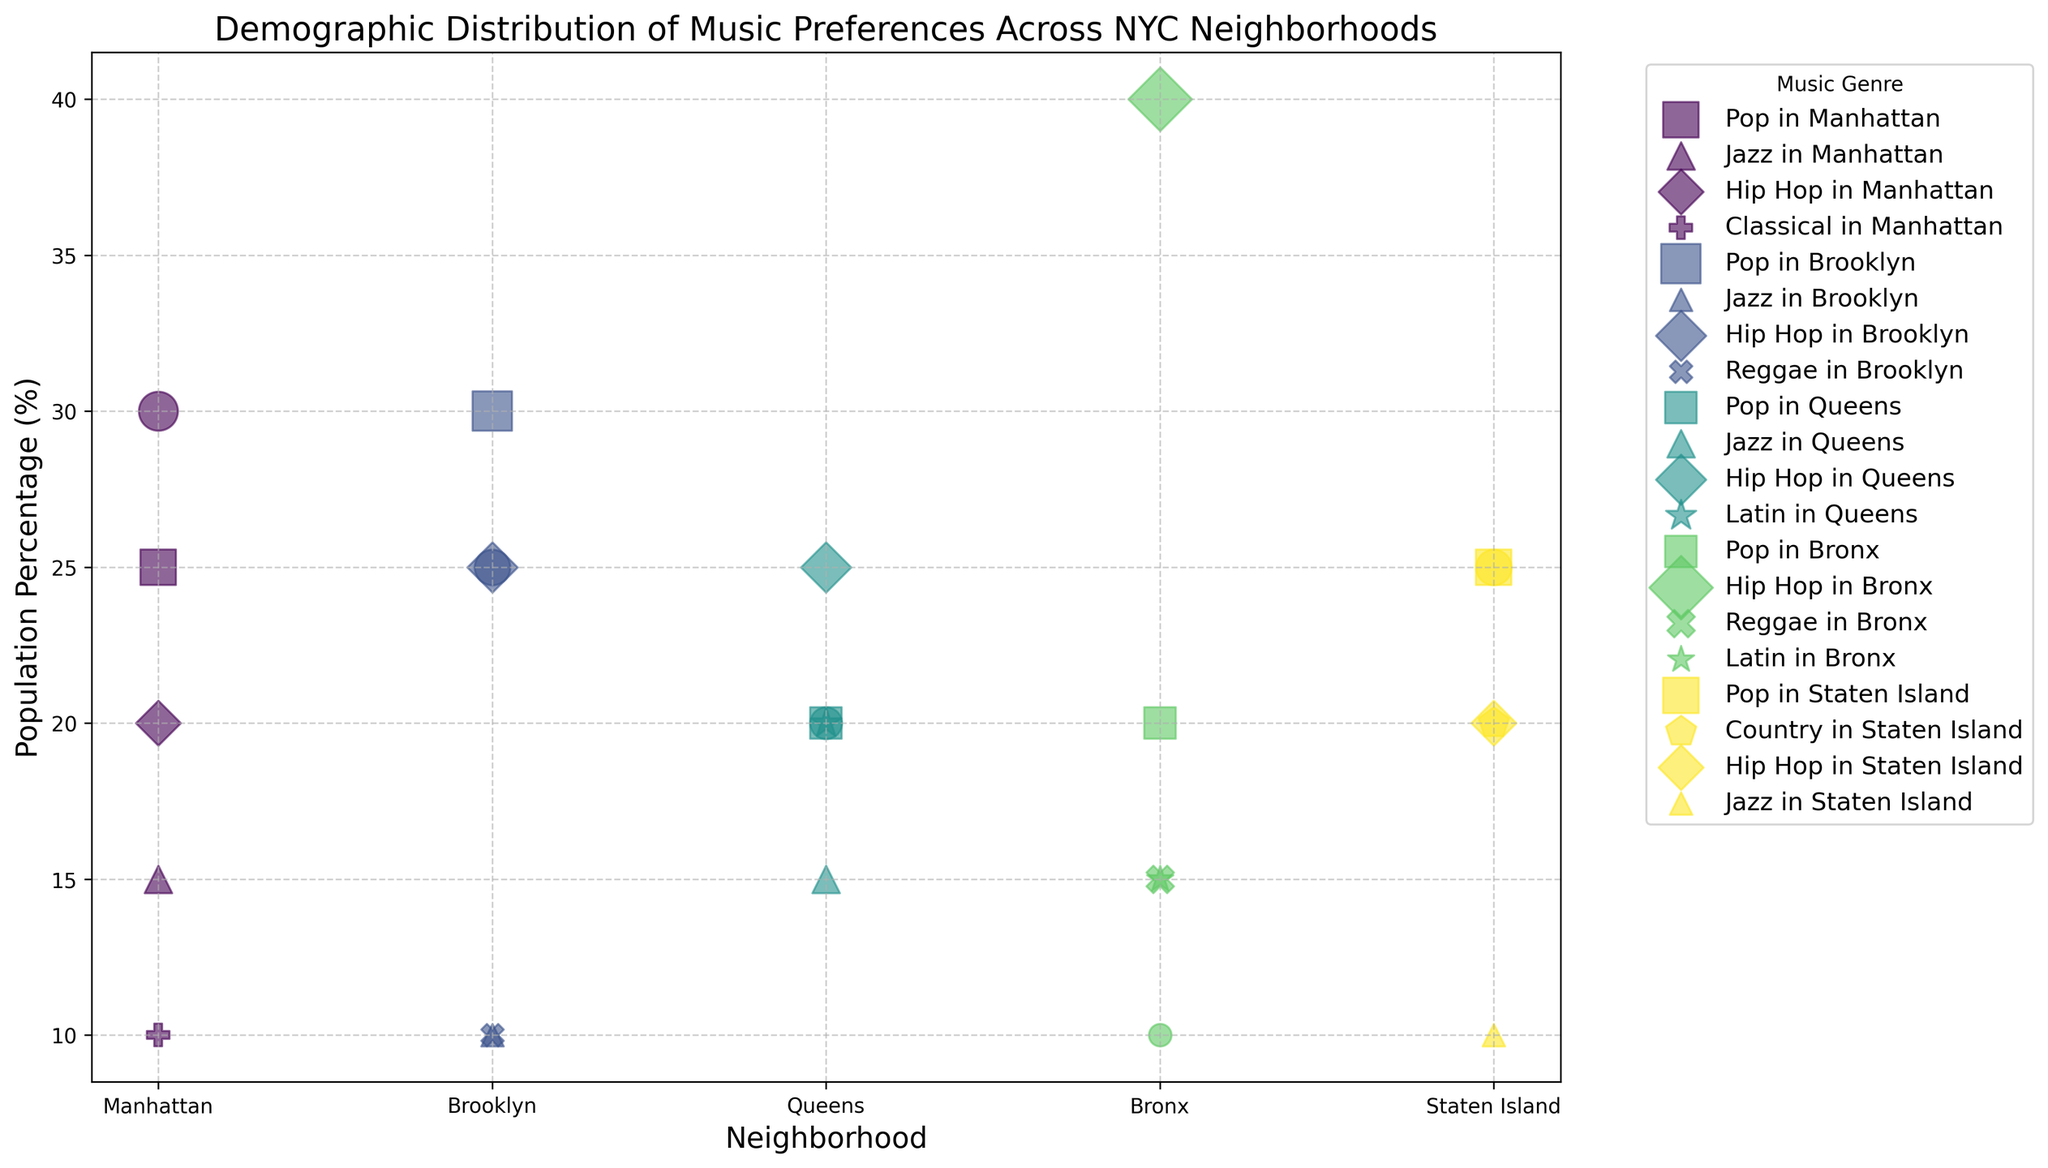What's the musical genre with the highest popularity in the Bronx? Look at which bubble has the largest y-value (population percentage) in the Bronx. The bubble representing Hip Hop has the highest percentage at 40%.
Answer: Hip Hop Which neighborhood has the highest population percentage for Jazz? Compare the y-values (population percentages) of Jazz across all neighborhoods. The highest y-value for Jazz is in Manhattan at 15%.
Answer: Manhattan Between Brooklyn and Staten Island, which neighborhood has a greater percentage of Pop listeners? Compare the Pop bubbles in Brooklyn and Staten Island. Both have y-values of 25% for Pop listeners.
Answer: Equal What's the average population percentage of Rock listeners in NYC? Sum the Rock population percentages across all neighborhoods (30 + 25 + 20 + 10 + 25 = 110) and divide by the number of neighborhoods (5). The average is 110/5 = 22.
Answer: 22 Is the percentage of Hip Hop listeners in Queens greater or less than in Staten Island? Compare the y-values of Hip Hop in Queens (25%) and Staten Island (20%). The percentage in Queens is greater.
Answer: Greater What is the difference between the highest and lowest population percentages for any genre across neighborhoods? Identify the highest y-value (Hip Hop in Bronx at 40%) and the lowest y-value (Classical in Manhattan and Jazz in Staten Island at 10%), then calculate the difference: 40 - 10 = 30.
Answer: 30 Which neighborhood shows diversity by having five different music genres with populations above 10%? Look for neighborhoods with at least five bubbles with y-values above 10%. Manhattan has Rock, Pop, Jazz, Hip Hop, and Classical all above 10%.
Answer: Manhattan How many music genres in total are represented in the Bronx? Count the different genres (Rock, Pop, Hip Hop, Reggae, and Latin) represented in the Bronx.
Answer: 5 What is the visual pattern for neighborhoods with high percentages of a single genre? Observe that neighborhoods with a single genre with a dominant bubble indicate a higher preference. For example, the Bronx shows a high percentage for Hip Hop as a larger bubble size.
Answer: Single large bubble 